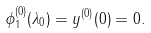Convert formula to latex. <formula><loc_0><loc_0><loc_500><loc_500>\phi _ { 1 } ^ { ( 0 ) } ( \lambda _ { 0 } ) = y ^ { ( 0 ) } ( 0 ) = 0 .</formula> 